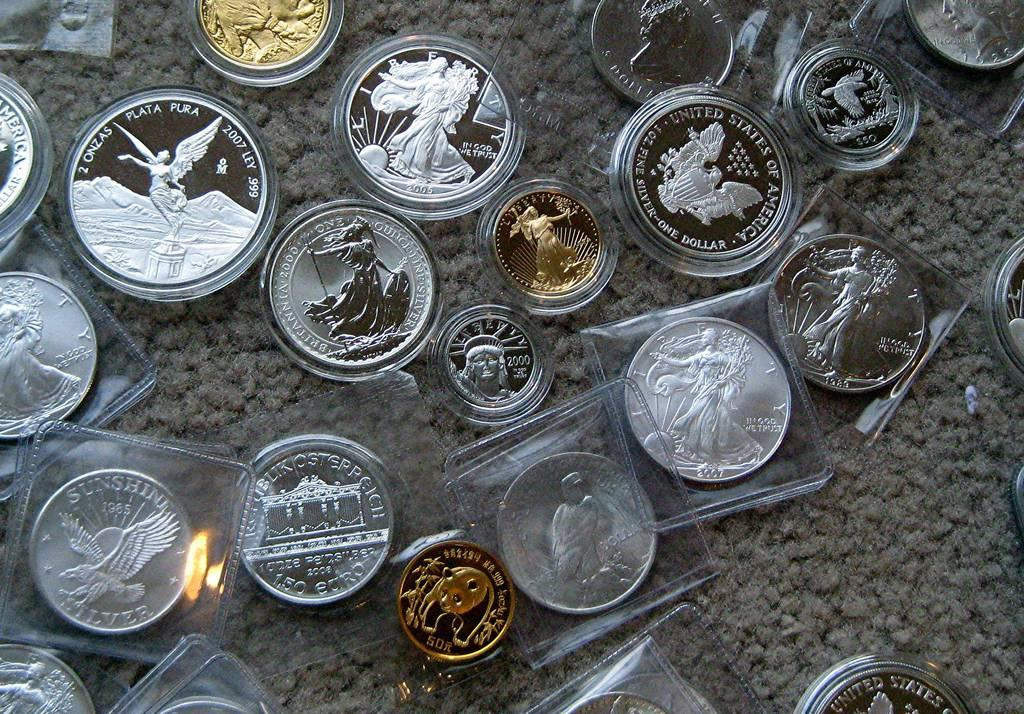What type of coins can be seen on the floor in the image? There are silver coins and gold coins on the floor in the image. Can you describe the color of the silver coins? The silver coins are likely a shiny, metallic color. How many types of coins are present on the floor? There are two types of coins present on the floor: silver and gold. Are there any berries growing on the coins in the image? There are no berries present in the image; it only features silver and gold coins on the floor. Can you see any cobwebs on the coins in the image? There is no mention of cobwebs in the image, and the focus is solely on the silver and gold coins on the floor. 